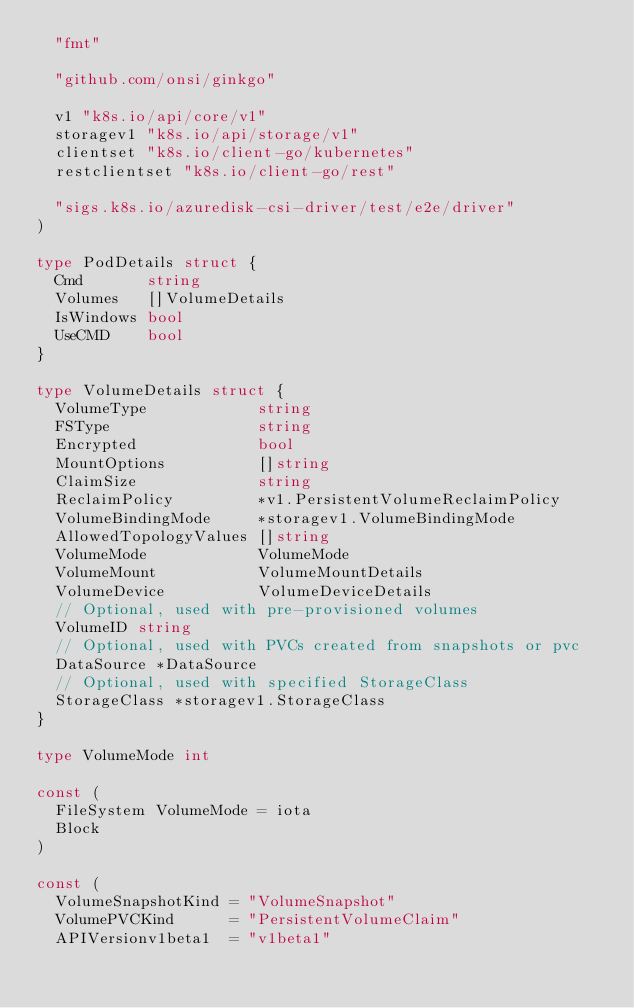<code> <loc_0><loc_0><loc_500><loc_500><_Go_>	"fmt"

	"github.com/onsi/ginkgo"

	v1 "k8s.io/api/core/v1"
	storagev1 "k8s.io/api/storage/v1"
	clientset "k8s.io/client-go/kubernetes"
	restclientset "k8s.io/client-go/rest"

	"sigs.k8s.io/azuredisk-csi-driver/test/e2e/driver"
)

type PodDetails struct {
	Cmd       string
	Volumes   []VolumeDetails
	IsWindows bool
	UseCMD    bool
}

type VolumeDetails struct {
	VolumeType            string
	FSType                string
	Encrypted             bool
	MountOptions          []string
	ClaimSize             string
	ReclaimPolicy         *v1.PersistentVolumeReclaimPolicy
	VolumeBindingMode     *storagev1.VolumeBindingMode
	AllowedTopologyValues []string
	VolumeMode            VolumeMode
	VolumeMount           VolumeMountDetails
	VolumeDevice          VolumeDeviceDetails
	// Optional, used with pre-provisioned volumes
	VolumeID string
	// Optional, used with PVCs created from snapshots or pvc
	DataSource *DataSource
	// Optional, used with specified StorageClass
	StorageClass *storagev1.StorageClass
}

type VolumeMode int

const (
	FileSystem VolumeMode = iota
	Block
)

const (
	VolumeSnapshotKind = "VolumeSnapshot"
	VolumePVCKind      = "PersistentVolumeClaim"
	APIVersionv1beta1  = "v1beta1"</code> 